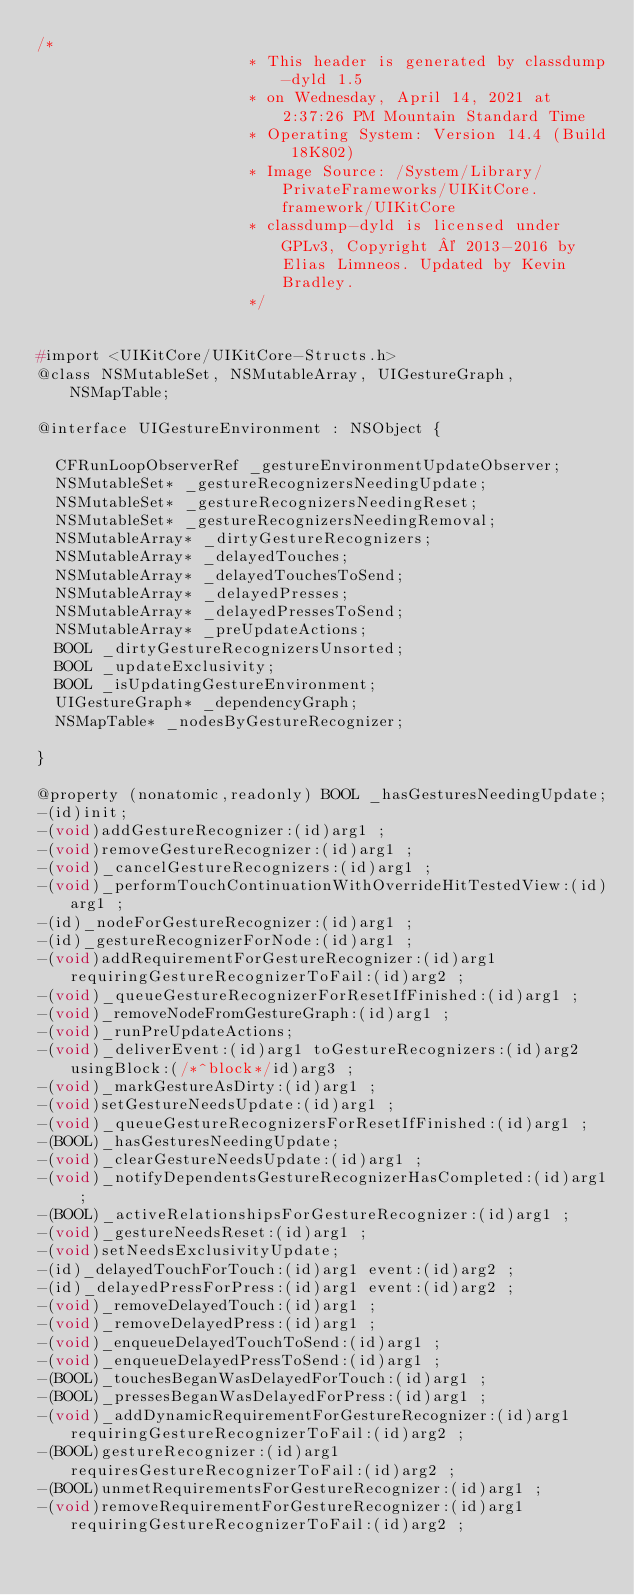Convert code to text. <code><loc_0><loc_0><loc_500><loc_500><_C_>/*
                       * This header is generated by classdump-dyld 1.5
                       * on Wednesday, April 14, 2021 at 2:37:26 PM Mountain Standard Time
                       * Operating System: Version 14.4 (Build 18K802)
                       * Image Source: /System/Library/PrivateFrameworks/UIKitCore.framework/UIKitCore
                       * classdump-dyld is licensed under GPLv3, Copyright © 2013-2016 by Elias Limneos. Updated by Kevin Bradley.
                       */


#import <UIKitCore/UIKitCore-Structs.h>
@class NSMutableSet, NSMutableArray, UIGestureGraph, NSMapTable;

@interface UIGestureEnvironment : NSObject {

	CFRunLoopObserverRef _gestureEnvironmentUpdateObserver;
	NSMutableSet* _gestureRecognizersNeedingUpdate;
	NSMutableSet* _gestureRecognizersNeedingReset;
	NSMutableSet* _gestureRecognizersNeedingRemoval;
	NSMutableArray* _dirtyGestureRecognizers;
	NSMutableArray* _delayedTouches;
	NSMutableArray* _delayedTouchesToSend;
	NSMutableArray* _delayedPresses;
	NSMutableArray* _delayedPressesToSend;
	NSMutableArray* _preUpdateActions;
	BOOL _dirtyGestureRecognizersUnsorted;
	BOOL _updateExclusivity;
	BOOL _isUpdatingGestureEnvironment;
	UIGestureGraph* _dependencyGraph;
	NSMapTable* _nodesByGestureRecognizer;

}

@property (nonatomic,readonly) BOOL _hasGesturesNeedingUpdate; 
-(id)init;
-(void)addGestureRecognizer:(id)arg1 ;
-(void)removeGestureRecognizer:(id)arg1 ;
-(void)_cancelGestureRecognizers:(id)arg1 ;
-(void)_performTouchContinuationWithOverrideHitTestedView:(id)arg1 ;
-(id)_nodeForGestureRecognizer:(id)arg1 ;
-(id)_gestureRecognizerForNode:(id)arg1 ;
-(void)addRequirementForGestureRecognizer:(id)arg1 requiringGestureRecognizerToFail:(id)arg2 ;
-(void)_queueGestureRecognizerForResetIfFinished:(id)arg1 ;
-(void)_removeNodeFromGestureGraph:(id)arg1 ;
-(void)_runPreUpdateActions;
-(void)_deliverEvent:(id)arg1 toGestureRecognizers:(id)arg2 usingBlock:(/*^block*/id)arg3 ;
-(void)_markGestureAsDirty:(id)arg1 ;
-(void)setGestureNeedsUpdate:(id)arg1 ;
-(void)_queueGestureRecognizersForResetIfFinished:(id)arg1 ;
-(BOOL)_hasGesturesNeedingUpdate;
-(void)_clearGestureNeedsUpdate:(id)arg1 ;
-(void)_notifyDependentsGestureRecognizerHasCompleted:(id)arg1 ;
-(BOOL)_activeRelationshipsForGestureRecognizer:(id)arg1 ;
-(void)_gestureNeedsReset:(id)arg1 ;
-(void)setNeedsExclusivityUpdate;
-(id)_delayedTouchForTouch:(id)arg1 event:(id)arg2 ;
-(id)_delayedPressForPress:(id)arg1 event:(id)arg2 ;
-(void)_removeDelayedTouch:(id)arg1 ;
-(void)_removeDelayedPress:(id)arg1 ;
-(void)_enqueueDelayedTouchToSend:(id)arg1 ;
-(void)_enqueueDelayedPressToSend:(id)arg1 ;
-(BOOL)_touchesBeganWasDelayedForTouch:(id)arg1 ;
-(BOOL)_pressesBeganWasDelayedForPress:(id)arg1 ;
-(void)_addDynamicRequirementForGestureRecognizer:(id)arg1 requiringGestureRecognizerToFail:(id)arg2 ;
-(BOOL)gestureRecognizer:(id)arg1 requiresGestureRecognizerToFail:(id)arg2 ;
-(BOOL)unmetRequirementsForGestureRecognizer:(id)arg1 ;
-(void)removeRequirementForGestureRecognizer:(id)arg1 requiringGestureRecognizerToFail:(id)arg2 ;</code> 